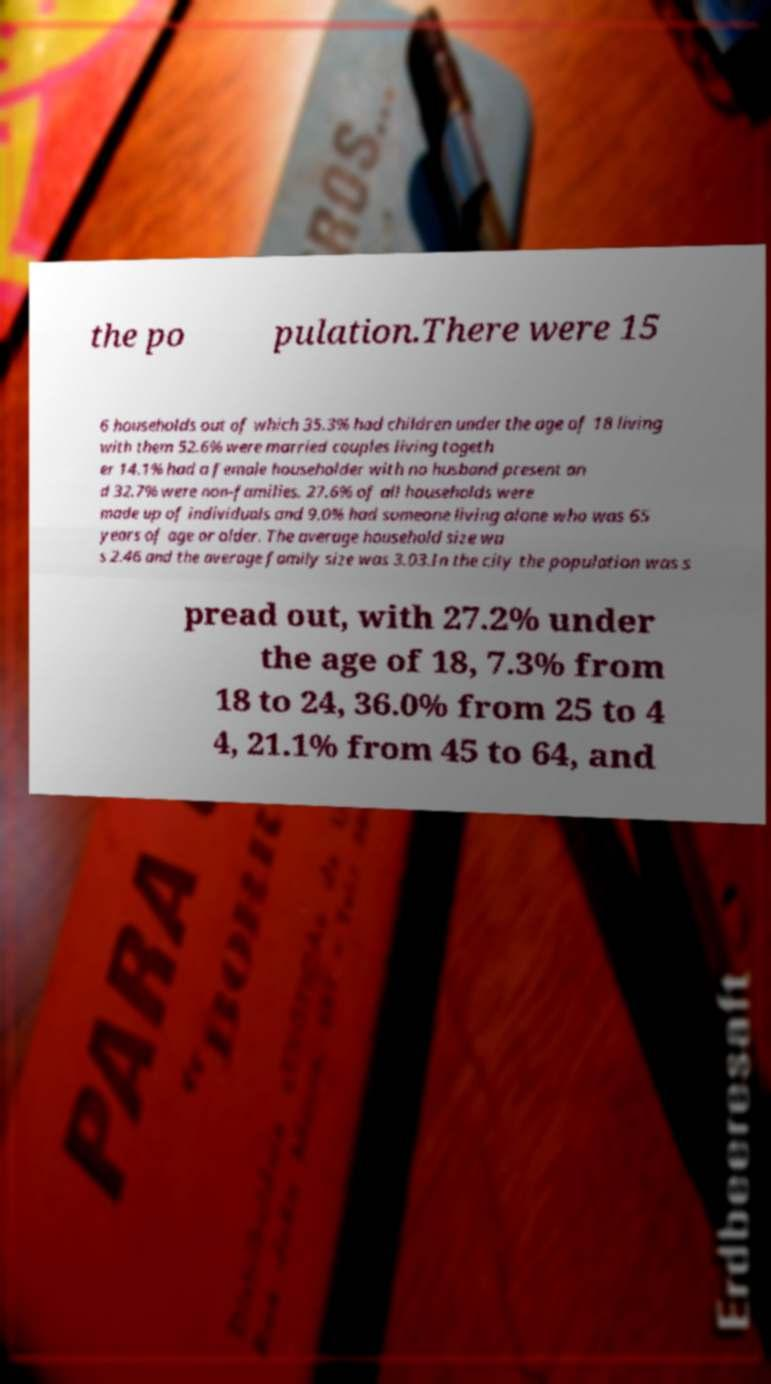Can you read and provide the text displayed in the image?This photo seems to have some interesting text. Can you extract and type it out for me? the po pulation.There were 15 6 households out of which 35.3% had children under the age of 18 living with them 52.6% were married couples living togeth er 14.1% had a female householder with no husband present an d 32.7% were non-families. 27.6% of all households were made up of individuals and 9.0% had someone living alone who was 65 years of age or older. The average household size wa s 2.46 and the average family size was 3.03.In the city the population was s pread out, with 27.2% under the age of 18, 7.3% from 18 to 24, 36.0% from 25 to 4 4, 21.1% from 45 to 64, and 